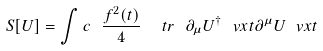Convert formula to latex. <formula><loc_0><loc_0><loc_500><loc_500>S [ U ] = \int c \ \frac { f ^ { 2 } ( t ) } { 4 } \ \ t r \ \partial _ { \mu } U ^ { \dagger } \ v x t \partial ^ { \mu } U \ v x t</formula> 